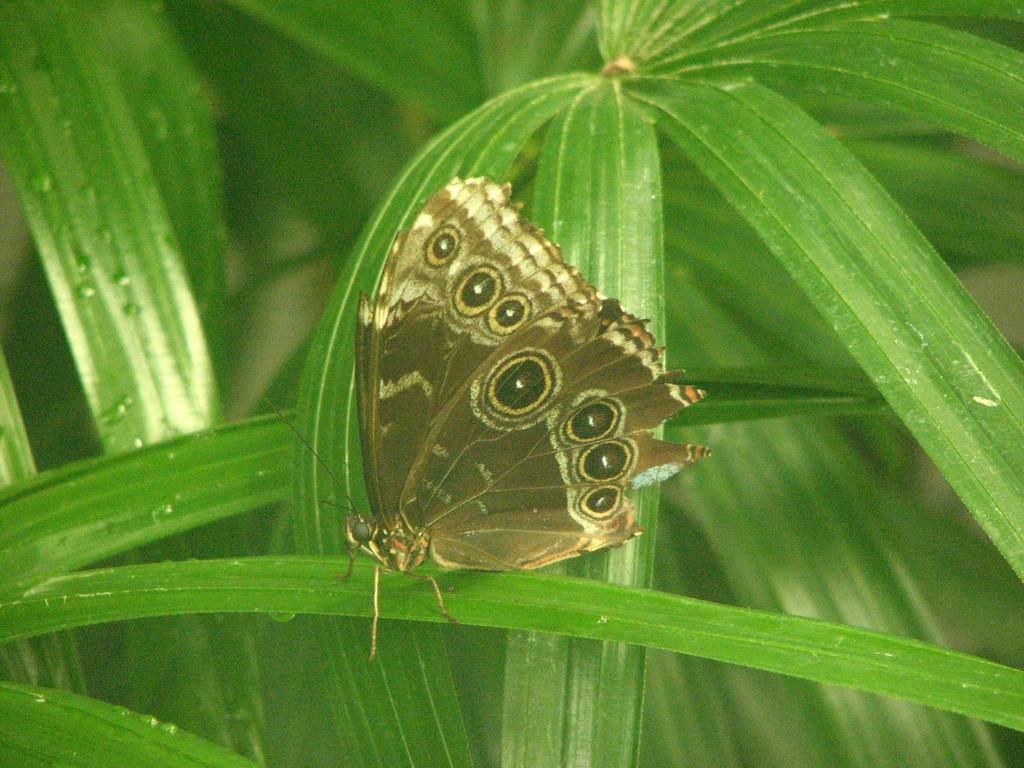How would you summarize this image in a sentence or two? In this picture we can see a butterfly and few leaves. 